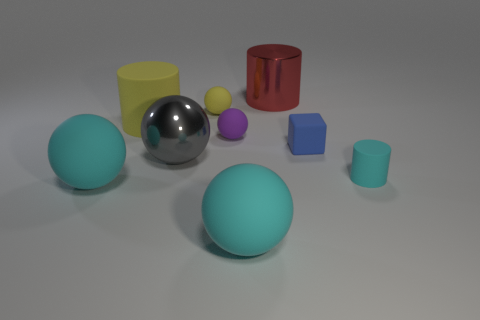Subtract 1 cylinders. How many cylinders are left? 2 Subtract all yellow balls. How many balls are left? 4 Subtract all matte cylinders. How many cylinders are left? 1 Add 1 blue things. How many objects exist? 10 Subtract all blue balls. Subtract all blue cubes. How many balls are left? 5 Subtract all cubes. How many objects are left? 8 Add 3 purple rubber balls. How many purple rubber balls exist? 4 Subtract 0 red cubes. How many objects are left? 9 Subtract all rubber blocks. Subtract all tiny green metallic blocks. How many objects are left? 8 Add 3 red metallic things. How many red metallic things are left? 4 